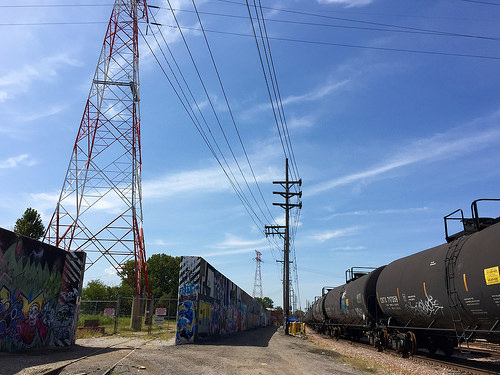<image>
Is the wall to the left of the tower? No. The wall is not to the left of the tower. From this viewpoint, they have a different horizontal relationship. Is there a power pole in front of the power pole? No. The power pole is not in front of the power pole. The spatial positioning shows a different relationship between these objects. 